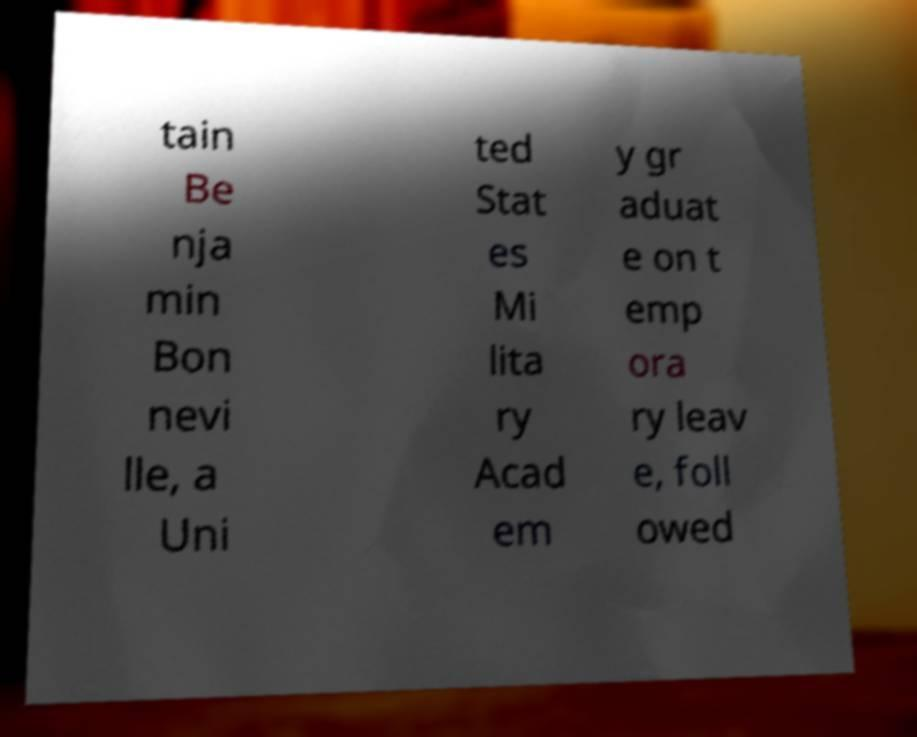For documentation purposes, I need the text within this image transcribed. Could you provide that? tain Be nja min Bon nevi lle, a Uni ted Stat es Mi lita ry Acad em y gr aduat e on t emp ora ry leav e, foll owed 